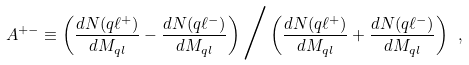<formula> <loc_0><loc_0><loc_500><loc_500>A ^ { + - } \equiv \left ( \frac { d N ( q \ell ^ { + } ) } { d M _ { q l } } - \frac { d N ( q \ell ^ { - } ) } { d M _ { q l } } \right ) \Big / \left ( \frac { d N ( q \ell ^ { + } ) } { d M _ { q l } } + \frac { d N ( q \ell ^ { - } ) } { d M _ { q l } } \right ) \ ,</formula> 